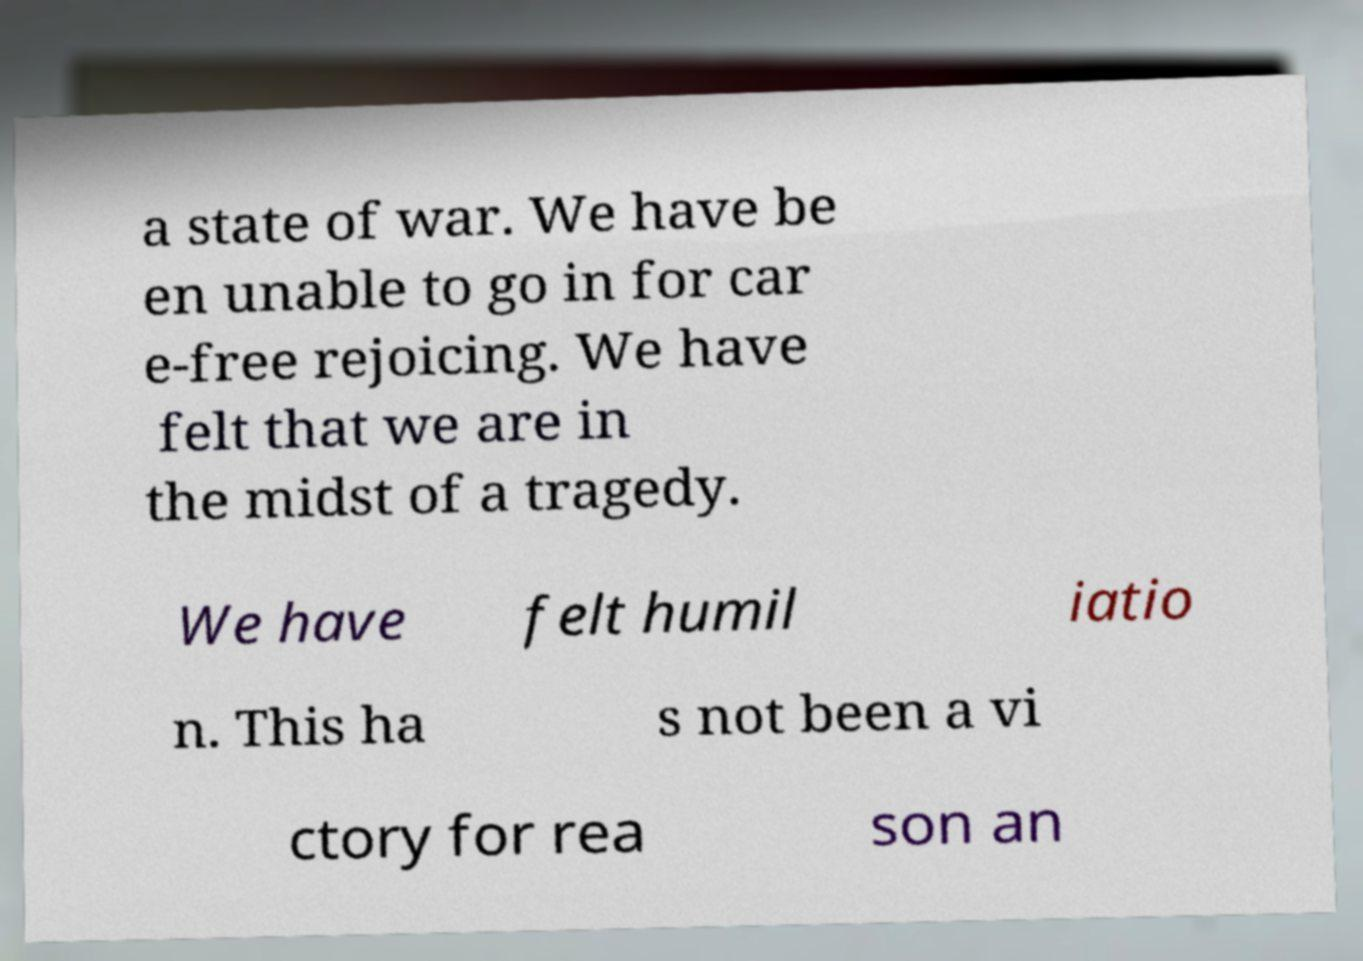What messages or text are displayed in this image? I need them in a readable, typed format. a state of war. We have be en unable to go in for car e-free rejoicing. We have felt that we are in the midst of a tragedy. We have felt humil iatio n. This ha s not been a vi ctory for rea son an 